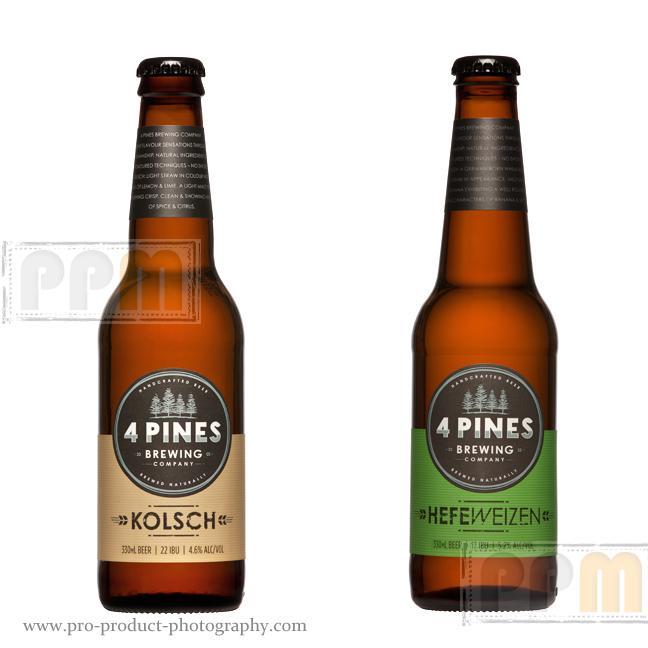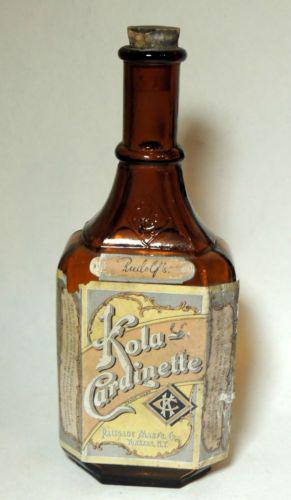The first image is the image on the left, the second image is the image on the right. Assess this claim about the two images: "There is no less than nine bottles.". Correct or not? Answer yes or no. No. The first image is the image on the left, the second image is the image on the right. Analyze the images presented: Is the assertion "There are more than 8 bottles." valid? Answer yes or no. No. 